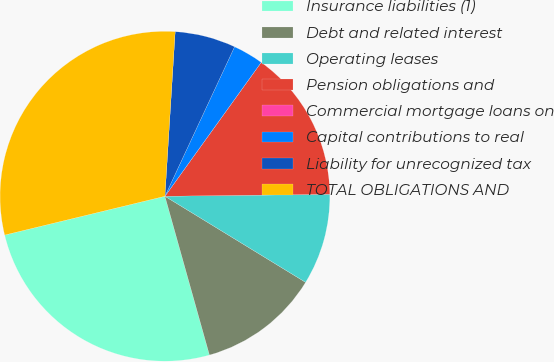Convert chart. <chart><loc_0><loc_0><loc_500><loc_500><pie_chart><fcel>Insurance liabilities (1)<fcel>Debt and related interest<fcel>Operating leases<fcel>Pension obligations and<fcel>Commercial mortgage loans on<fcel>Capital contributions to real<fcel>Liability for unrecognized tax<fcel>TOTAL OBLIGATIONS AND<nl><fcel>25.57%<fcel>11.91%<fcel>8.93%<fcel>14.89%<fcel>0.0%<fcel>2.98%<fcel>5.95%<fcel>29.77%<nl></chart> 